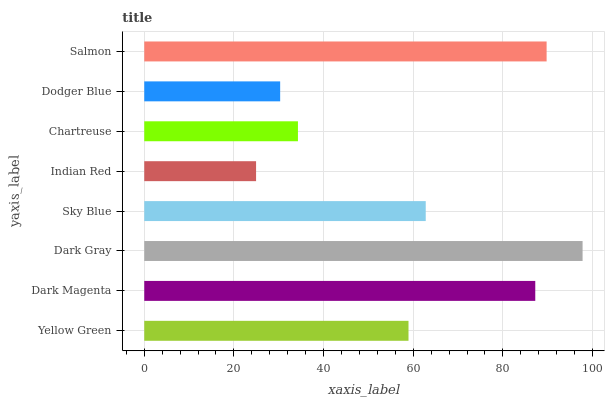Is Indian Red the minimum?
Answer yes or no. Yes. Is Dark Gray the maximum?
Answer yes or no. Yes. Is Dark Magenta the minimum?
Answer yes or no. No. Is Dark Magenta the maximum?
Answer yes or no. No. Is Dark Magenta greater than Yellow Green?
Answer yes or no. Yes. Is Yellow Green less than Dark Magenta?
Answer yes or no. Yes. Is Yellow Green greater than Dark Magenta?
Answer yes or no. No. Is Dark Magenta less than Yellow Green?
Answer yes or no. No. Is Sky Blue the high median?
Answer yes or no. Yes. Is Yellow Green the low median?
Answer yes or no. Yes. Is Dark Magenta the high median?
Answer yes or no. No. Is Indian Red the low median?
Answer yes or no. No. 